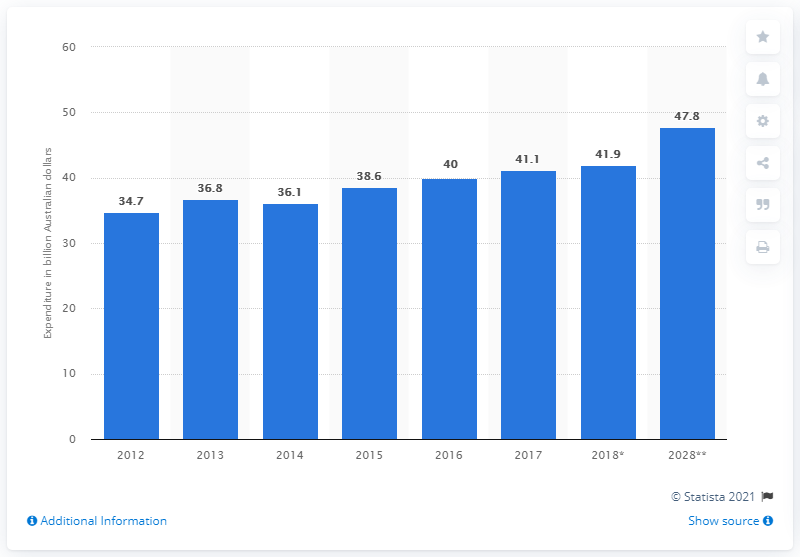Identify some key points in this picture. The forecast amount of outbound travel expenditure in Australia in 2028 was expected to be 47.8 billion Australian dollars. 